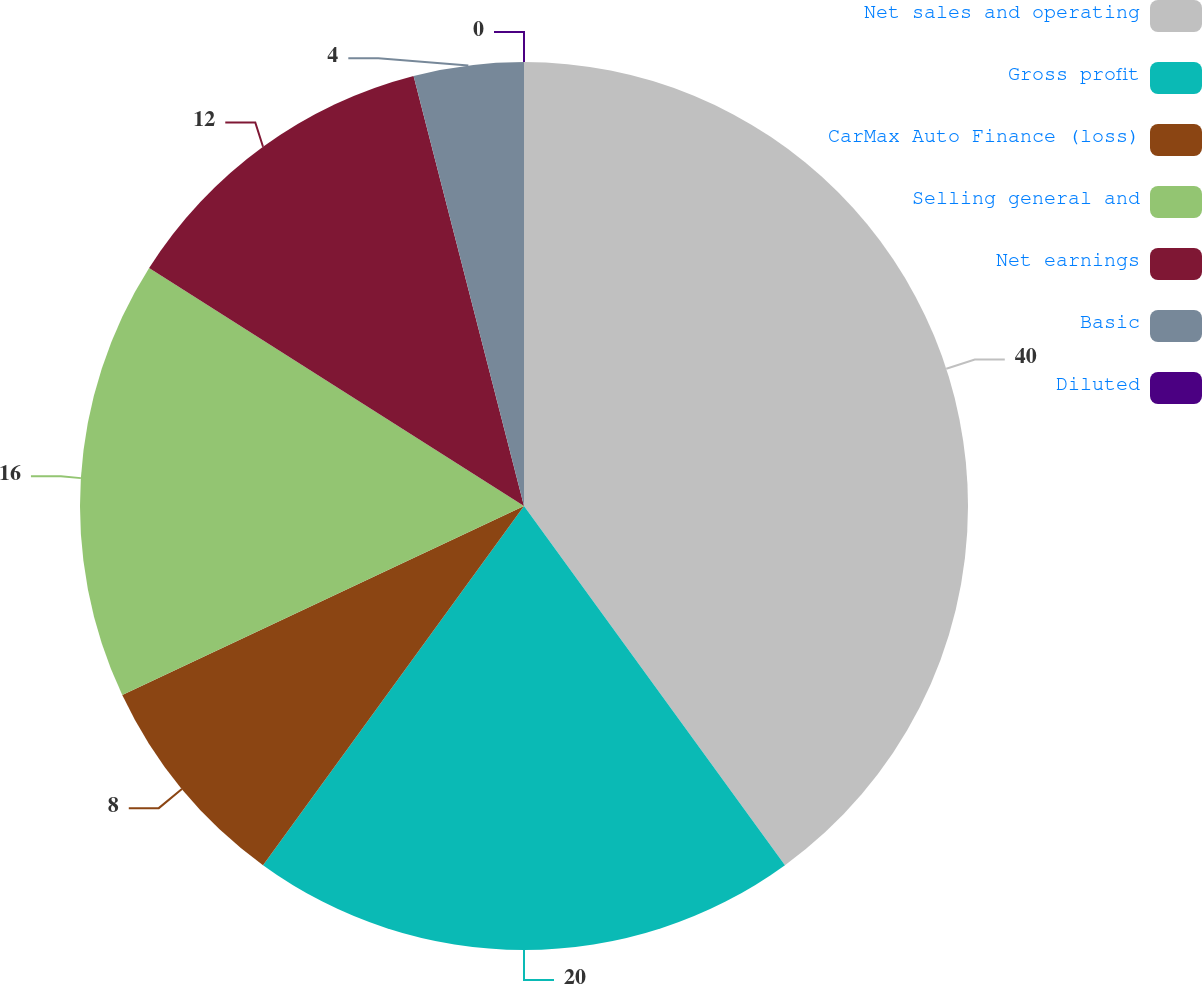<chart> <loc_0><loc_0><loc_500><loc_500><pie_chart><fcel>Net sales and operating<fcel>Gross profit<fcel>CarMax Auto Finance (loss)<fcel>Selling general and<fcel>Net earnings<fcel>Basic<fcel>Diluted<nl><fcel>40.0%<fcel>20.0%<fcel>8.0%<fcel>16.0%<fcel>12.0%<fcel>4.0%<fcel>0.0%<nl></chart> 